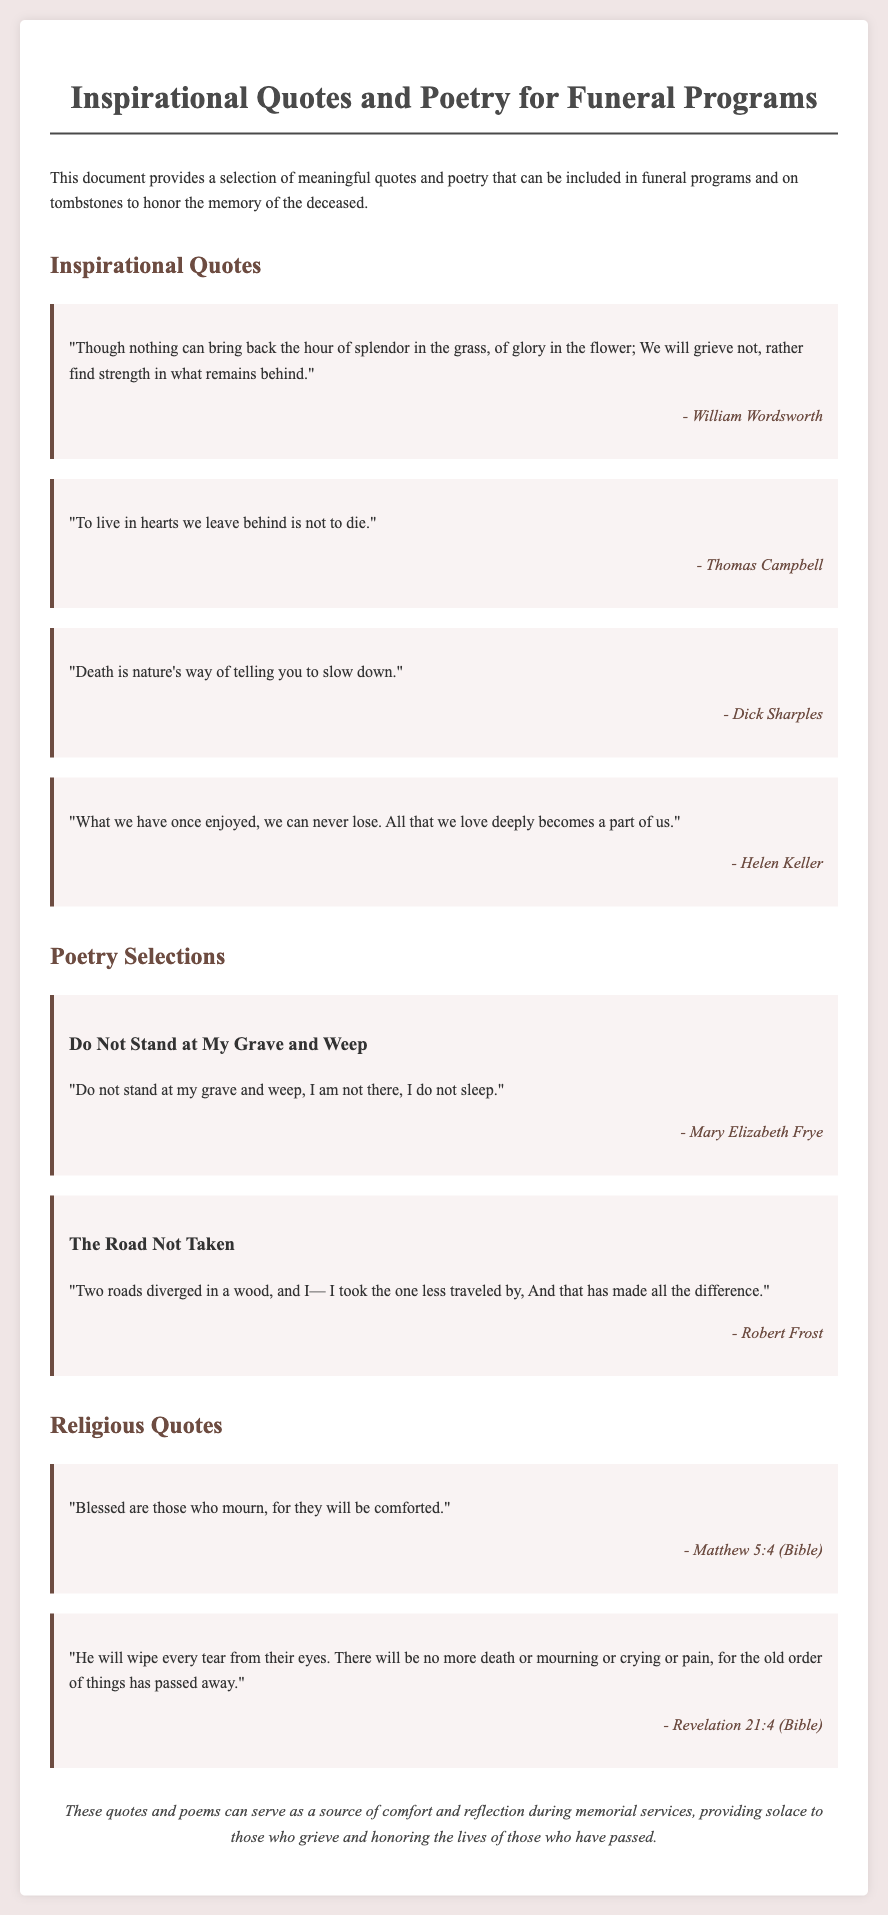What is the title of the document? The title is stated in the <title> tag and the main heading of the document.
Answer: Inspirational Quotes and Poetry for Funeral Programs Who is the author of the quote "What we have once enjoyed, we can never lose."? The author is mentioned below the quote in italics.
Answer: Helen Keller How many poems are included in the document? The number of poems can be counted in the poetry section.
Answer: 2 What is the first line of the poem "Do Not Stand at My Grave and Weep"? The first line of the poem is part of the text provided for that poem.
Answer: Do not stand at my grave and weep, I am not there, I do not sleep What scripture is quoted under Religious Quotes? The specific scripture references can be found in the Religious Quotes section.
Answer: Matthew 5:4 (Bible) Which quote talks about living in hearts we leave behind? The specific quote can be found in the Inspirational Quotes section.
Answer: To live in hearts we leave behind is not to die What is the background color of the document? The background color is specified in the CSS style section.
Answer: #f0e6e6 